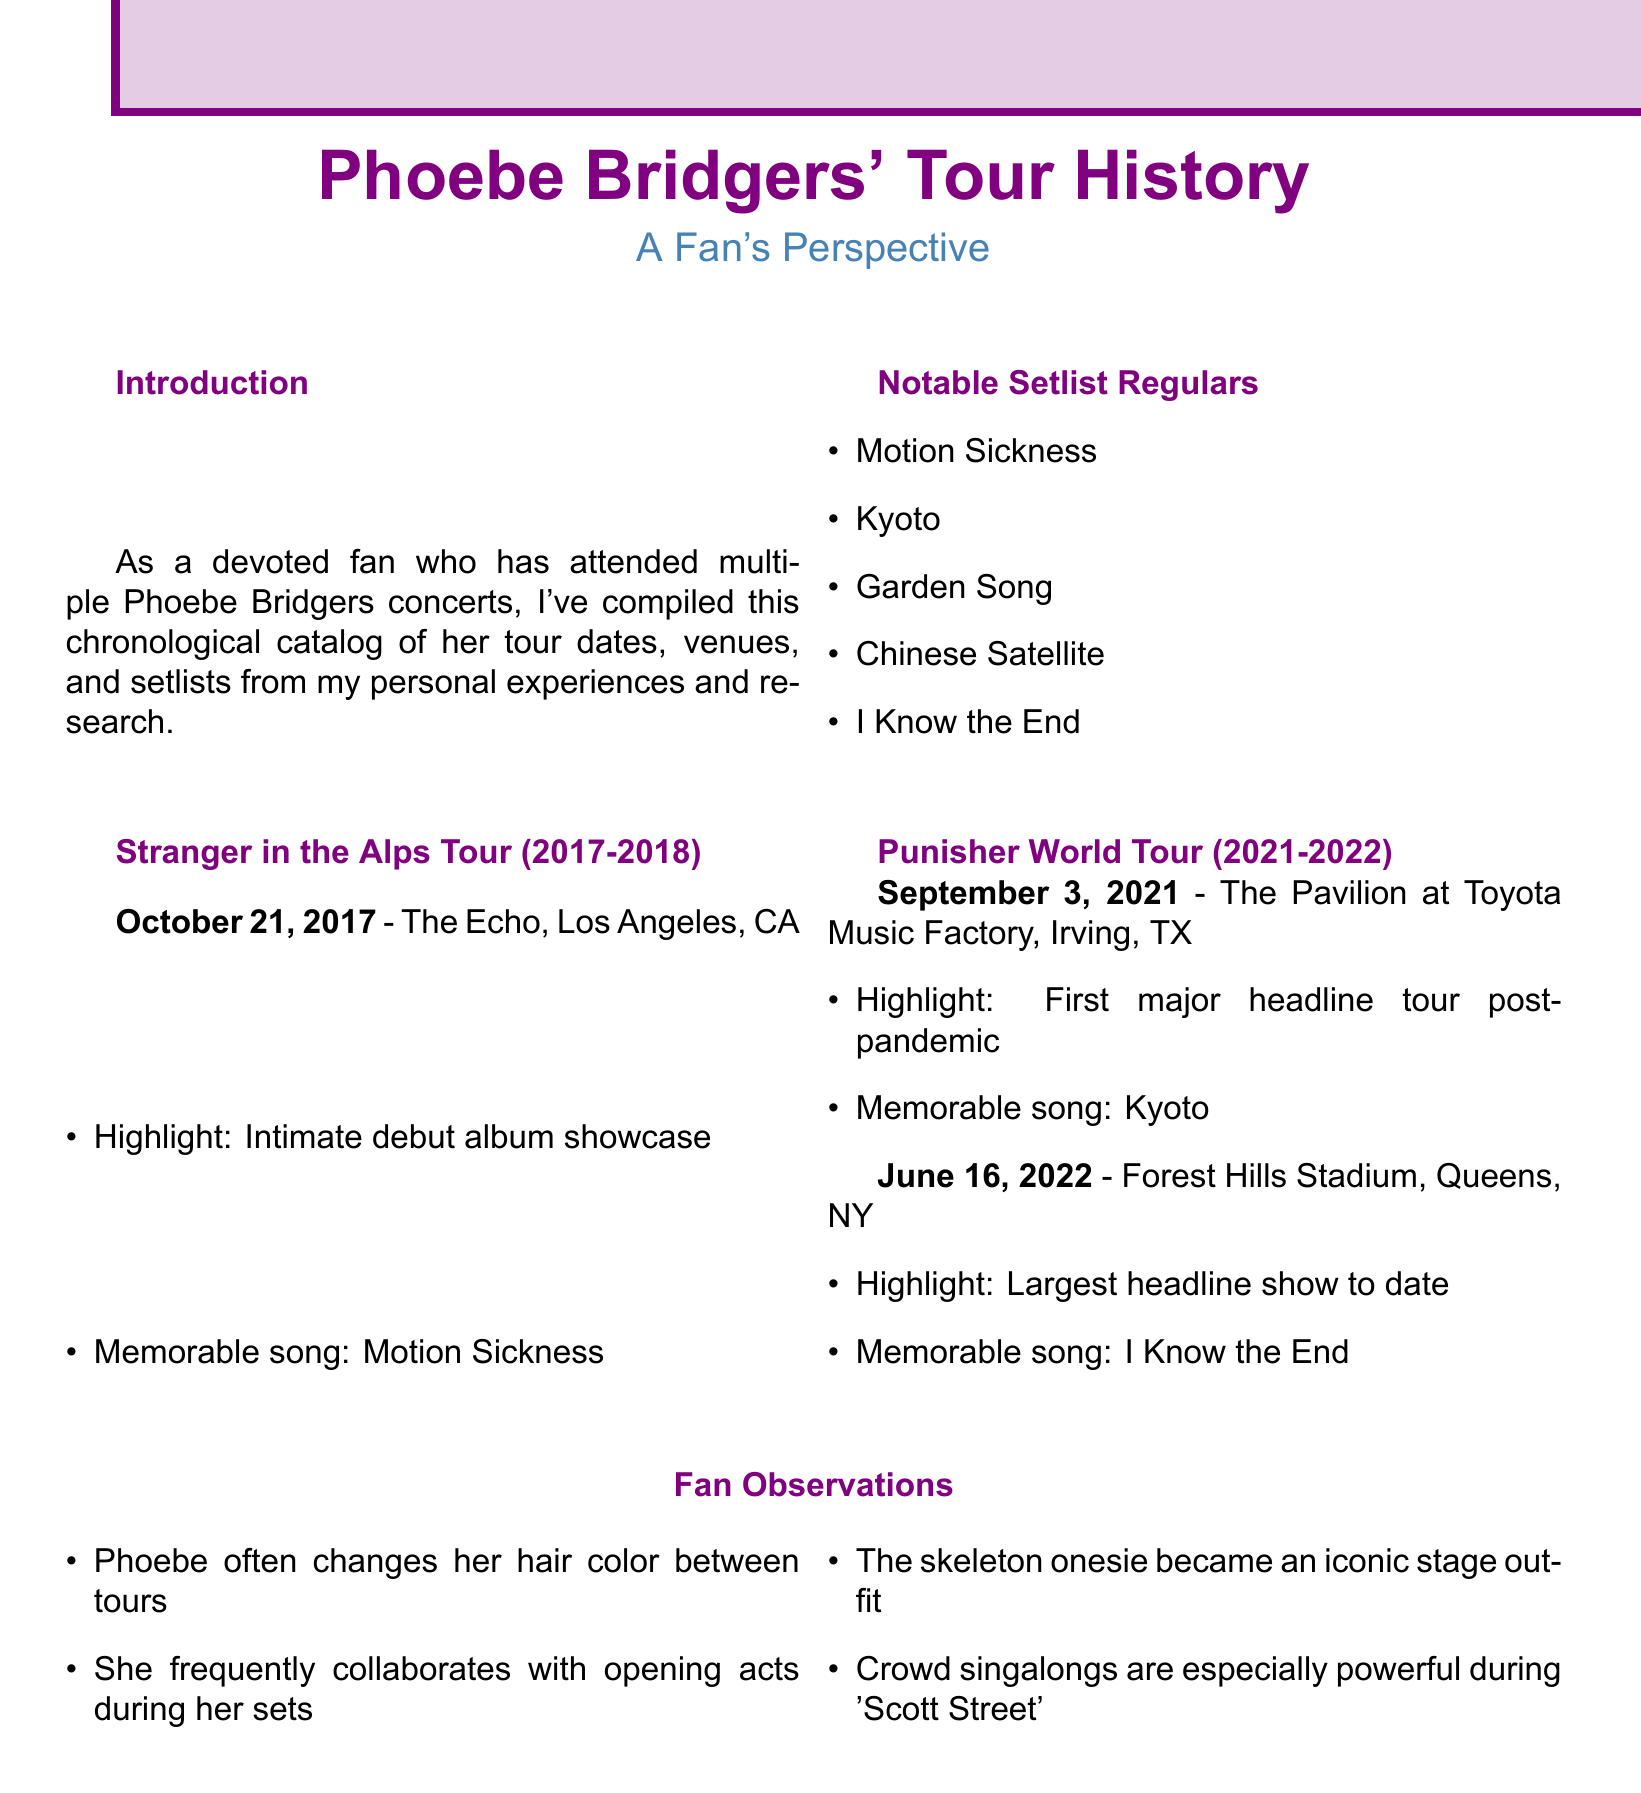What date did Phoebe Bridgers perform at The Echo? The document lists October 21, 2017, as the performance date at The Echo.
Answer: October 21, 2017 What is a memorable song from the Punisher World Tour in 2021? The document states that a memorable song performed on September 3, 2021, was Kyoto.
Answer: Kyoto How many notable setlist regulars are mentioned? The document lists five notable setlist regulars.
Answer: Five What was the highlight of the June 16, 2022 concert? The document notes that the highlight was the largest headline show to date.
Answer: Largest headline show Which song is mentioned as a powerful crowd singalong? The document mentions Scott Street as having powerful crowd singalongs.
Answer: Scott Street What iconic outfit did Phoebe Bridgers wear on stage? The document refers to the skeleton onesie as an iconic stage outfit.
Answer: Skeleton onesie What was Phoebe's first major headline tour post-pandemic? The document states that the tour starting on September 3, 2021, was her first major headline tour post-pandemic.
Answer: Punisher World Tour What is the title of the document? The document's title is Phoebe Bridgers' Tour History.
Answer: Phoebe Bridgers' Tour History 